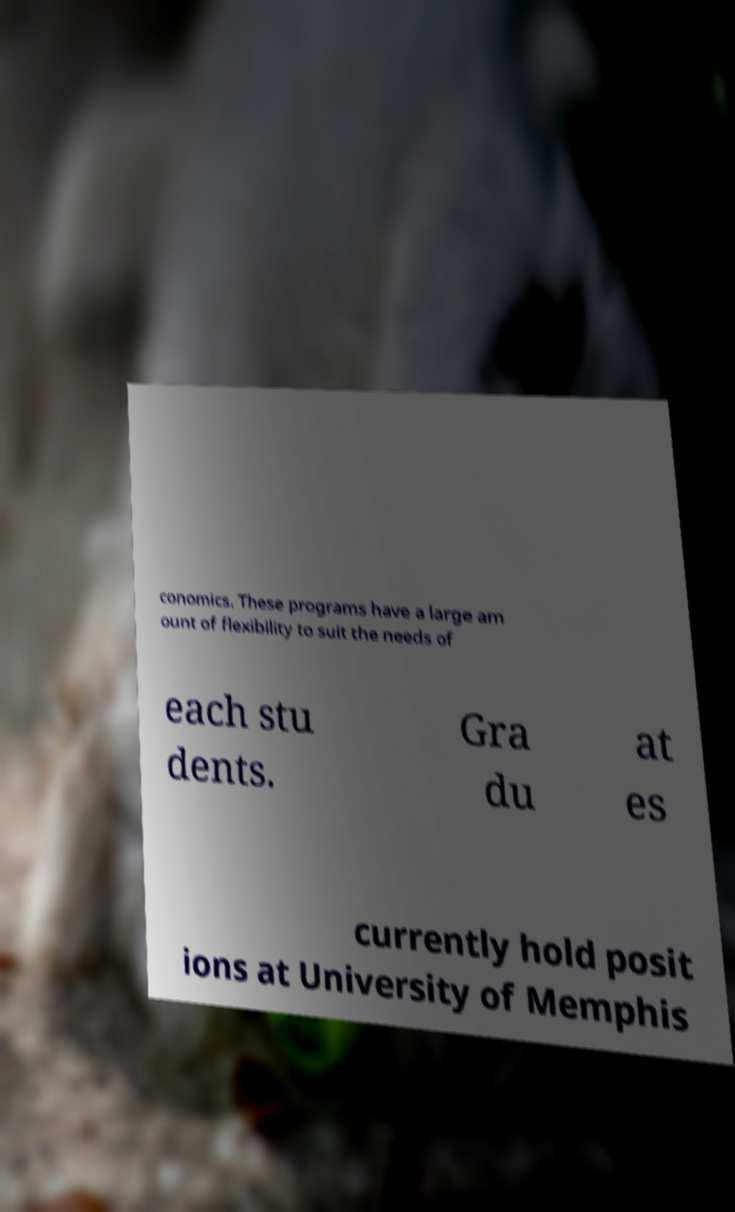Could you assist in decoding the text presented in this image and type it out clearly? conomics. These programs have a large am ount of flexibility to suit the needs of each stu dents. Gra du at es currently hold posit ions at University of Memphis 